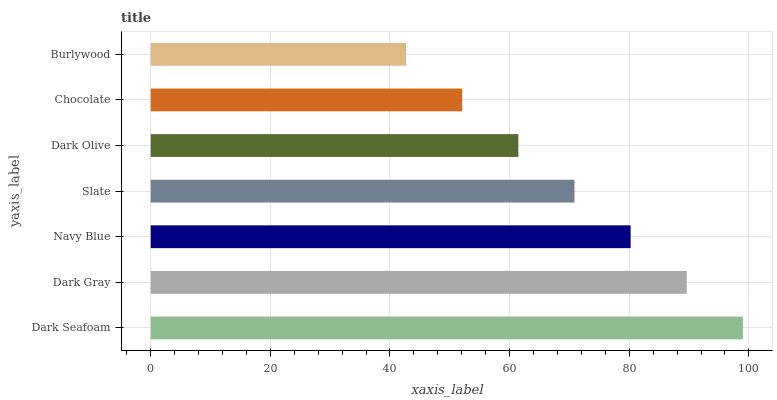Is Burlywood the minimum?
Answer yes or no. Yes. Is Dark Seafoam the maximum?
Answer yes or no. Yes. Is Dark Gray the minimum?
Answer yes or no. No. Is Dark Gray the maximum?
Answer yes or no. No. Is Dark Seafoam greater than Dark Gray?
Answer yes or no. Yes. Is Dark Gray less than Dark Seafoam?
Answer yes or no. Yes. Is Dark Gray greater than Dark Seafoam?
Answer yes or no. No. Is Dark Seafoam less than Dark Gray?
Answer yes or no. No. Is Slate the high median?
Answer yes or no. Yes. Is Slate the low median?
Answer yes or no. Yes. Is Navy Blue the high median?
Answer yes or no. No. Is Dark Olive the low median?
Answer yes or no. No. 